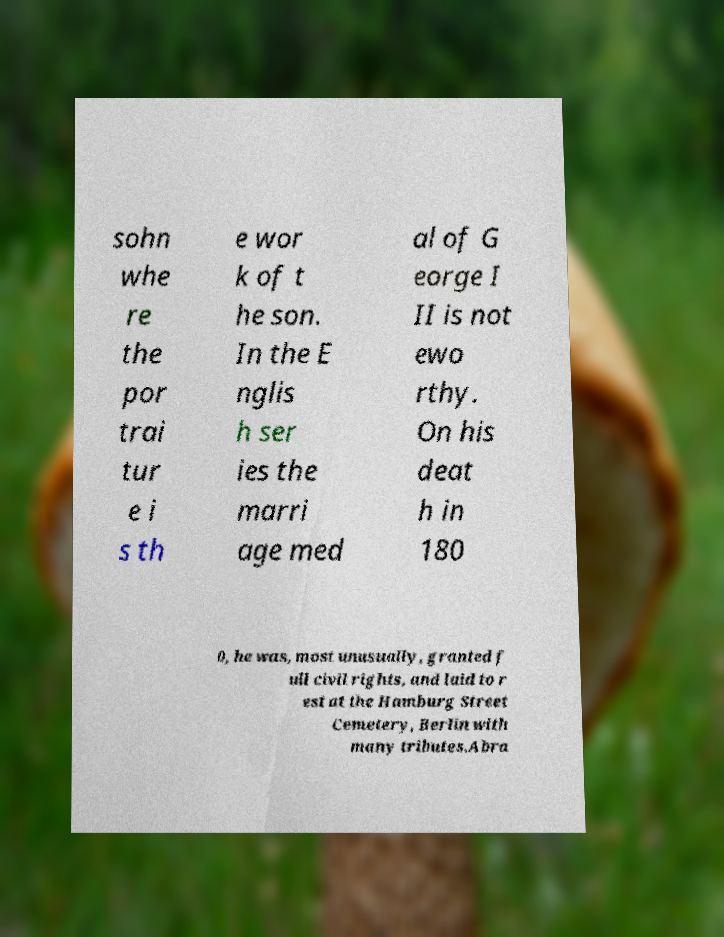For documentation purposes, I need the text within this image transcribed. Could you provide that? sohn whe re the por trai tur e i s th e wor k of t he son. In the E nglis h ser ies the marri age med al of G eorge I II is not ewo rthy. On his deat h in 180 0, he was, most unusually, granted f ull civil rights, and laid to r est at the Hamburg Street Cemetery, Berlin with many tributes.Abra 